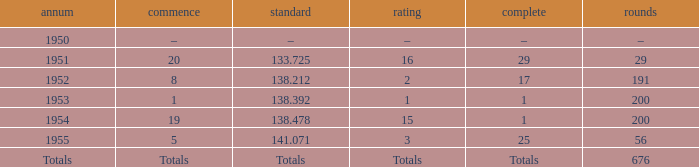What ranking that had a start of 19? 15.0. 